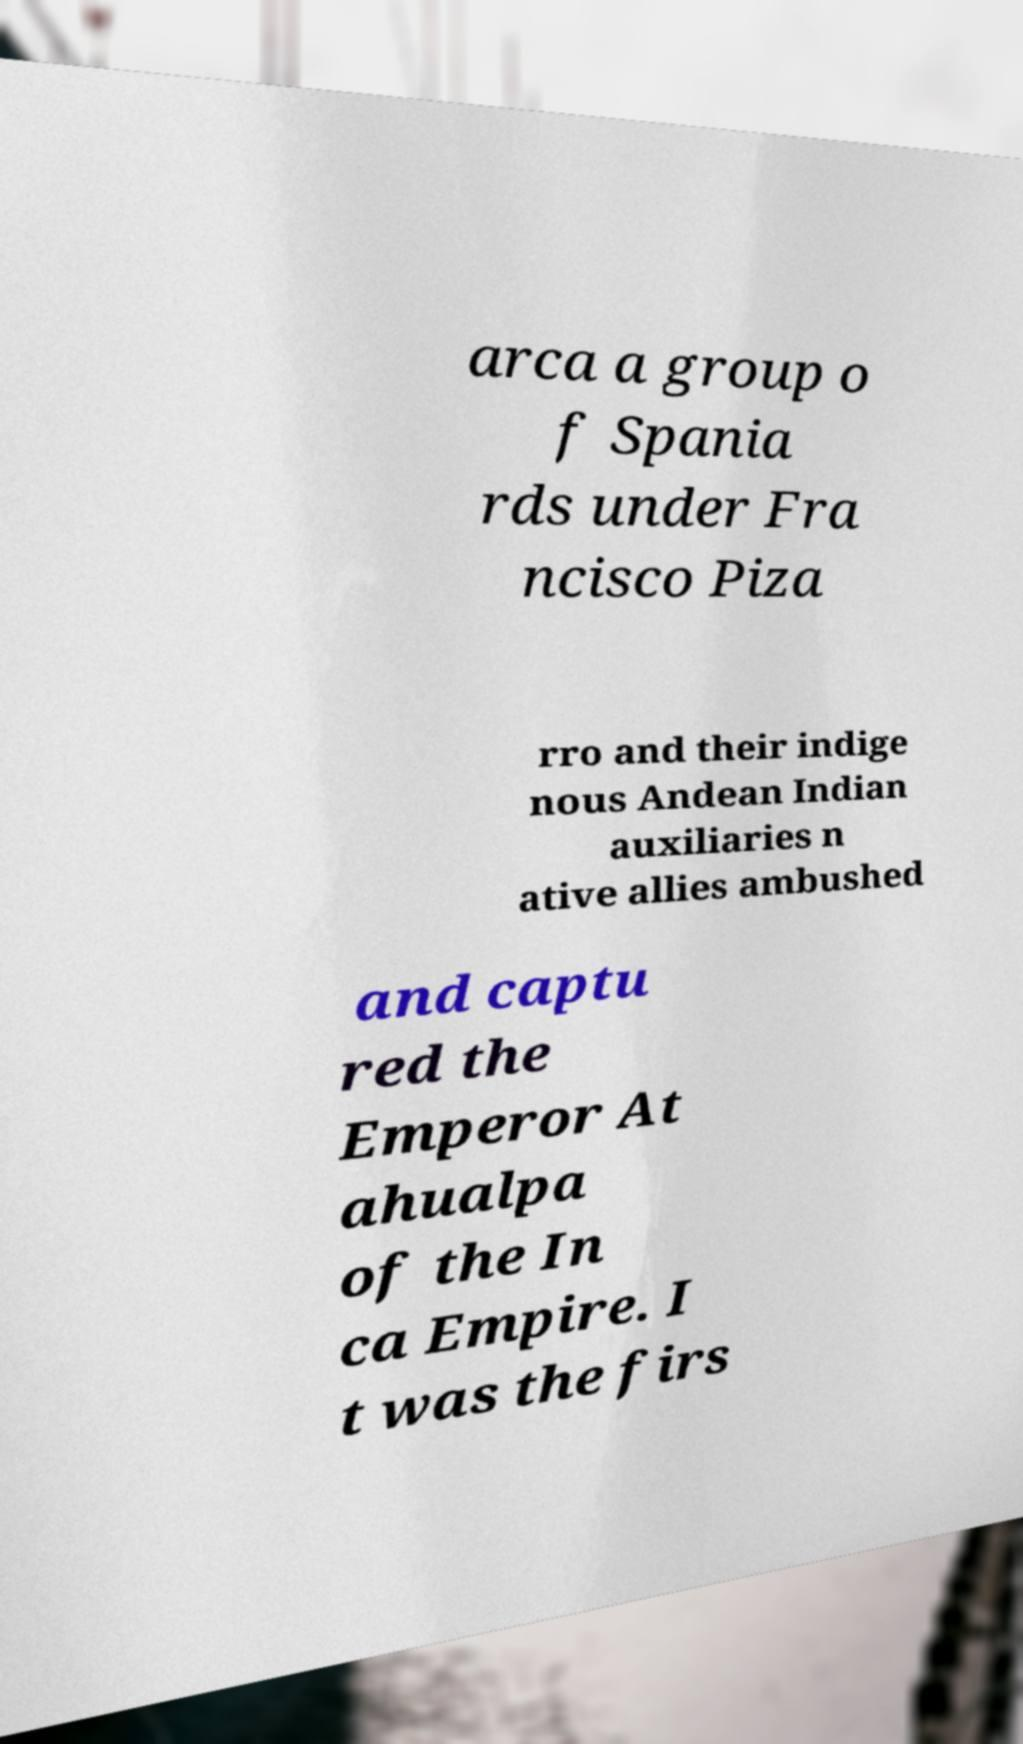Can you accurately transcribe the text from the provided image for me? arca a group o f Spania rds under Fra ncisco Piza rro and their indige nous Andean Indian auxiliaries n ative allies ambushed and captu red the Emperor At ahualpa of the In ca Empire. I t was the firs 